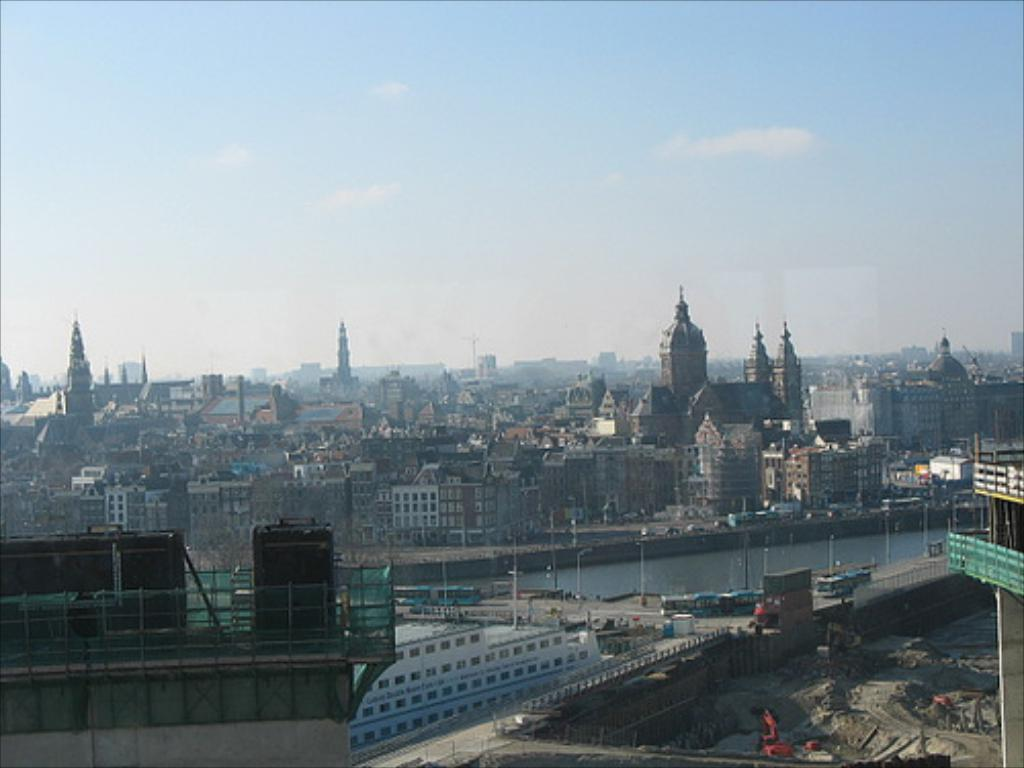What is the main structure in the center of the image? There is a building in the center of the image. What type of vehicles can be seen in the image? Buses are present in the image. What is the surface on which the buses are traveling? There is a road in the image. What natural element is visible in the image? Water is visible in the image. What are the tall, thin objects in the image? Poles are present in the image. What can be seen at the bottom of the image? The ground is visible at the bottom of the image. What is present at the top of the image? The sky is present at the top of the image. How many women are visible in the image? There are no women present in the image; it primarily features a building, buses, a road, water, poles, the ground, and the sky. --- Facts: 1. There is a person sitting on a chair in the image. 2. The person is holding a book. 3. The chair is made of wood. 4. There is a table next to the chair. 5. The table has a lamp on it. 6. The background of the image is a wall. Absurd Topics: elephant, ocean, bicycle Conversation: What is the person in the image doing? The person is sitting on a chair in the image. What is the person holding while sitting on the chair? The person is holding a book. What material is the chair made of? The chair is made of wood. What is located next to the chair? There is a table next to the chair. What object is on the table? The table has a lamp on it. What is visible behind the chair and table? The background of the image is a wall. Reasoning: Let's think step by step in order to produce the conversation. We start by identifying the main subject in the image, which is the person sitting on a chair. Then, we expand the conversation to include other elements that are also visible, such as the book, the chair's material, the table, the lamp, and the wall. Each question is designed to elicit a specific detail about the image that is known from the provided facts. Absurd Question/Answer: 